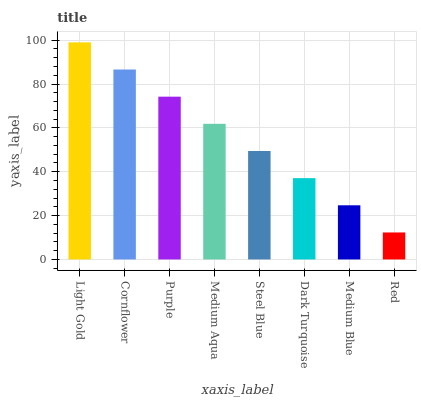Is Red the minimum?
Answer yes or no. Yes. Is Light Gold the maximum?
Answer yes or no. Yes. Is Cornflower the minimum?
Answer yes or no. No. Is Cornflower the maximum?
Answer yes or no. No. Is Light Gold greater than Cornflower?
Answer yes or no. Yes. Is Cornflower less than Light Gold?
Answer yes or no. Yes. Is Cornflower greater than Light Gold?
Answer yes or no. No. Is Light Gold less than Cornflower?
Answer yes or no. No. Is Medium Aqua the high median?
Answer yes or no. Yes. Is Steel Blue the low median?
Answer yes or no. Yes. Is Cornflower the high median?
Answer yes or no. No. Is Light Gold the low median?
Answer yes or no. No. 